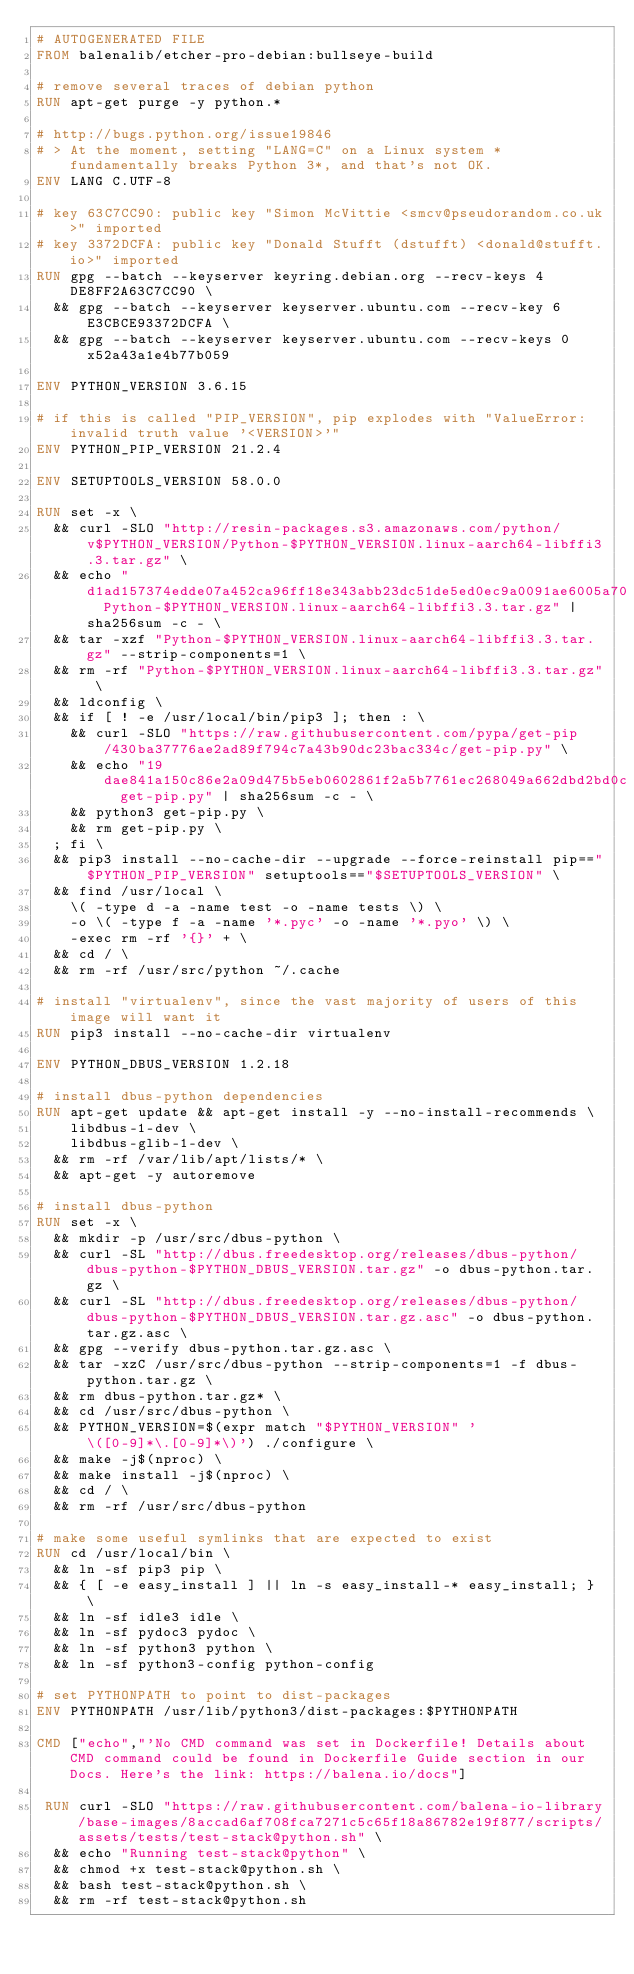Convert code to text. <code><loc_0><loc_0><loc_500><loc_500><_Dockerfile_># AUTOGENERATED FILE
FROM balenalib/etcher-pro-debian:bullseye-build

# remove several traces of debian python
RUN apt-get purge -y python.*

# http://bugs.python.org/issue19846
# > At the moment, setting "LANG=C" on a Linux system *fundamentally breaks Python 3*, and that's not OK.
ENV LANG C.UTF-8

# key 63C7CC90: public key "Simon McVittie <smcv@pseudorandom.co.uk>" imported
# key 3372DCFA: public key "Donald Stufft (dstufft) <donald@stufft.io>" imported
RUN gpg --batch --keyserver keyring.debian.org --recv-keys 4DE8FF2A63C7CC90 \
	&& gpg --batch --keyserver keyserver.ubuntu.com --recv-key 6E3CBCE93372DCFA \
	&& gpg --batch --keyserver keyserver.ubuntu.com --recv-keys 0x52a43a1e4b77b059

ENV PYTHON_VERSION 3.6.15

# if this is called "PIP_VERSION", pip explodes with "ValueError: invalid truth value '<VERSION>'"
ENV PYTHON_PIP_VERSION 21.2.4

ENV SETUPTOOLS_VERSION 58.0.0

RUN set -x \
	&& curl -SLO "http://resin-packages.s3.amazonaws.com/python/v$PYTHON_VERSION/Python-$PYTHON_VERSION.linux-aarch64-libffi3.3.tar.gz" \
	&& echo "d1ad157374edde07a452ca96ff18e343abb23dc51de5ed0ec9a0091ae6005a70  Python-$PYTHON_VERSION.linux-aarch64-libffi3.3.tar.gz" | sha256sum -c - \
	&& tar -xzf "Python-$PYTHON_VERSION.linux-aarch64-libffi3.3.tar.gz" --strip-components=1 \
	&& rm -rf "Python-$PYTHON_VERSION.linux-aarch64-libffi3.3.tar.gz" \
	&& ldconfig \
	&& if [ ! -e /usr/local/bin/pip3 ]; then : \
		&& curl -SLO "https://raw.githubusercontent.com/pypa/get-pip/430ba37776ae2ad89f794c7a43b90dc23bac334c/get-pip.py" \
		&& echo "19dae841a150c86e2a09d475b5eb0602861f2a5b7761ec268049a662dbd2bd0c  get-pip.py" | sha256sum -c - \
		&& python3 get-pip.py \
		&& rm get-pip.py \
	; fi \
	&& pip3 install --no-cache-dir --upgrade --force-reinstall pip=="$PYTHON_PIP_VERSION" setuptools=="$SETUPTOOLS_VERSION" \
	&& find /usr/local \
		\( -type d -a -name test -o -name tests \) \
		-o \( -type f -a -name '*.pyc' -o -name '*.pyo' \) \
		-exec rm -rf '{}' + \
	&& cd / \
	&& rm -rf /usr/src/python ~/.cache

# install "virtualenv", since the vast majority of users of this image will want it
RUN pip3 install --no-cache-dir virtualenv

ENV PYTHON_DBUS_VERSION 1.2.18

# install dbus-python dependencies 
RUN apt-get update && apt-get install -y --no-install-recommends \
		libdbus-1-dev \
		libdbus-glib-1-dev \
	&& rm -rf /var/lib/apt/lists/* \
	&& apt-get -y autoremove

# install dbus-python
RUN set -x \
	&& mkdir -p /usr/src/dbus-python \
	&& curl -SL "http://dbus.freedesktop.org/releases/dbus-python/dbus-python-$PYTHON_DBUS_VERSION.tar.gz" -o dbus-python.tar.gz \
	&& curl -SL "http://dbus.freedesktop.org/releases/dbus-python/dbus-python-$PYTHON_DBUS_VERSION.tar.gz.asc" -o dbus-python.tar.gz.asc \
	&& gpg --verify dbus-python.tar.gz.asc \
	&& tar -xzC /usr/src/dbus-python --strip-components=1 -f dbus-python.tar.gz \
	&& rm dbus-python.tar.gz* \
	&& cd /usr/src/dbus-python \
	&& PYTHON_VERSION=$(expr match "$PYTHON_VERSION" '\([0-9]*\.[0-9]*\)') ./configure \
	&& make -j$(nproc) \
	&& make install -j$(nproc) \
	&& cd / \
	&& rm -rf /usr/src/dbus-python

# make some useful symlinks that are expected to exist
RUN cd /usr/local/bin \
	&& ln -sf pip3 pip \
	&& { [ -e easy_install ] || ln -s easy_install-* easy_install; } \
	&& ln -sf idle3 idle \
	&& ln -sf pydoc3 pydoc \
	&& ln -sf python3 python \
	&& ln -sf python3-config python-config

# set PYTHONPATH to point to dist-packages
ENV PYTHONPATH /usr/lib/python3/dist-packages:$PYTHONPATH

CMD ["echo","'No CMD command was set in Dockerfile! Details about CMD command could be found in Dockerfile Guide section in our Docs. Here's the link: https://balena.io/docs"]

 RUN curl -SLO "https://raw.githubusercontent.com/balena-io-library/base-images/8accad6af708fca7271c5c65f18a86782e19f877/scripts/assets/tests/test-stack@python.sh" \
  && echo "Running test-stack@python" \
  && chmod +x test-stack@python.sh \
  && bash test-stack@python.sh \
  && rm -rf test-stack@python.sh 
</code> 